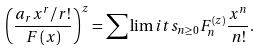<formula> <loc_0><loc_0><loc_500><loc_500>\left ( { \frac { a _ { r } x ^ { r } / r ! } { F \left ( x \right ) } } \right ) ^ { z } = \sum \lim i t s _ { n \geq 0 } { F _ { n } ^ { \left ( z \right ) } \frac { x ^ { n } } { n ! } } .</formula> 